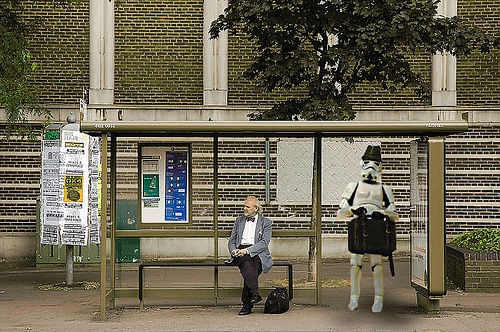Describe the objects in this image and their specific colors. I can see people in black, darkgray, olive, and gray tones, people in black, gray, darkgray, and white tones, suitcase in black, darkgreen, gray, and darkgray tones, bench in black, darkgreen, and gray tones, and handbag in black, gray, and darkgreen tones in this image. 